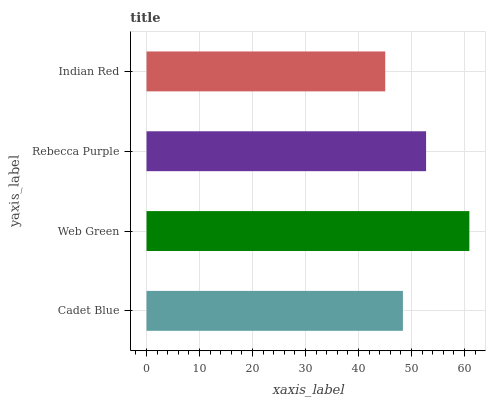Is Indian Red the minimum?
Answer yes or no. Yes. Is Web Green the maximum?
Answer yes or no. Yes. Is Rebecca Purple the minimum?
Answer yes or no. No. Is Rebecca Purple the maximum?
Answer yes or no. No. Is Web Green greater than Rebecca Purple?
Answer yes or no. Yes. Is Rebecca Purple less than Web Green?
Answer yes or no. Yes. Is Rebecca Purple greater than Web Green?
Answer yes or no. No. Is Web Green less than Rebecca Purple?
Answer yes or no. No. Is Rebecca Purple the high median?
Answer yes or no. Yes. Is Cadet Blue the low median?
Answer yes or no. Yes. Is Indian Red the high median?
Answer yes or no. No. Is Indian Red the low median?
Answer yes or no. No. 